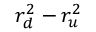<formula> <loc_0><loc_0><loc_500><loc_500>r _ { d } ^ { 2 } - r _ { u } ^ { 2 }</formula> 